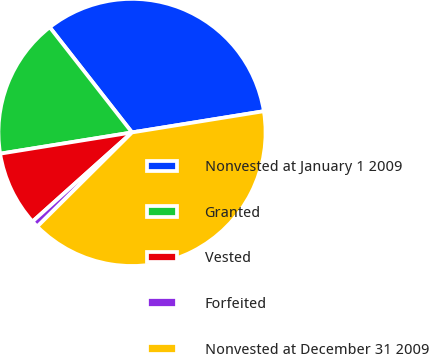Convert chart. <chart><loc_0><loc_0><loc_500><loc_500><pie_chart><fcel>Nonvested at January 1 2009<fcel>Granted<fcel>Vested<fcel>Forfeited<fcel>Nonvested at December 31 2009<nl><fcel>33.02%<fcel>16.98%<fcel>9.08%<fcel>0.83%<fcel>40.09%<nl></chart> 